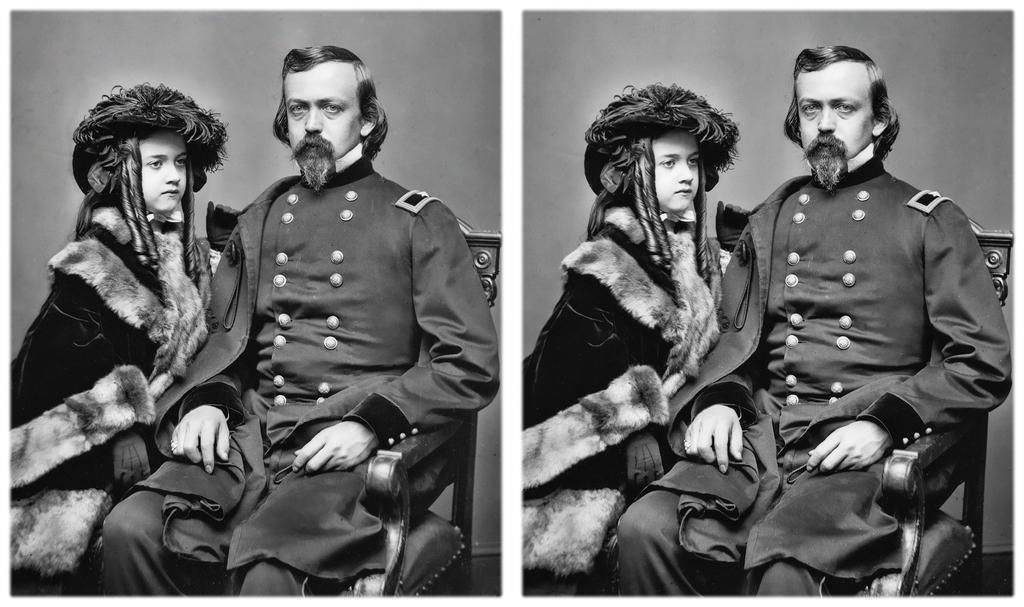What type of image is being described? The image is a collage. What color scheme is used in the image? The image is in black and white. What is the man in the image doing? The man is sitting on a chair in the image. Who is near the man in the image? There is a child standing near the man in the image. What type of celery is being used as a prop in the image? There is no celery present in the image. Can you describe the route the bat takes in the image? There is no bat present in the image, so it is not possible to describe a route. 